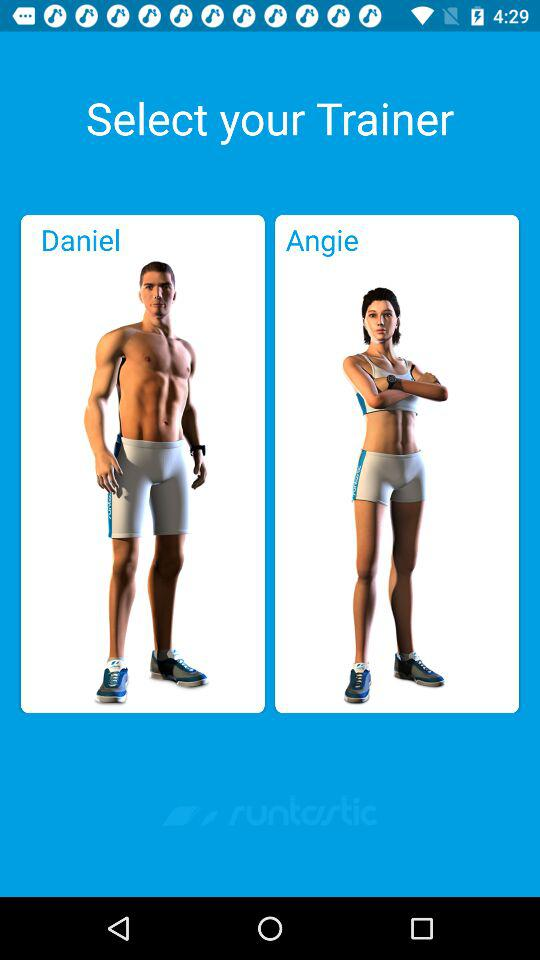How many trainers are there to choose from?
Answer the question using a single word or phrase. 2 